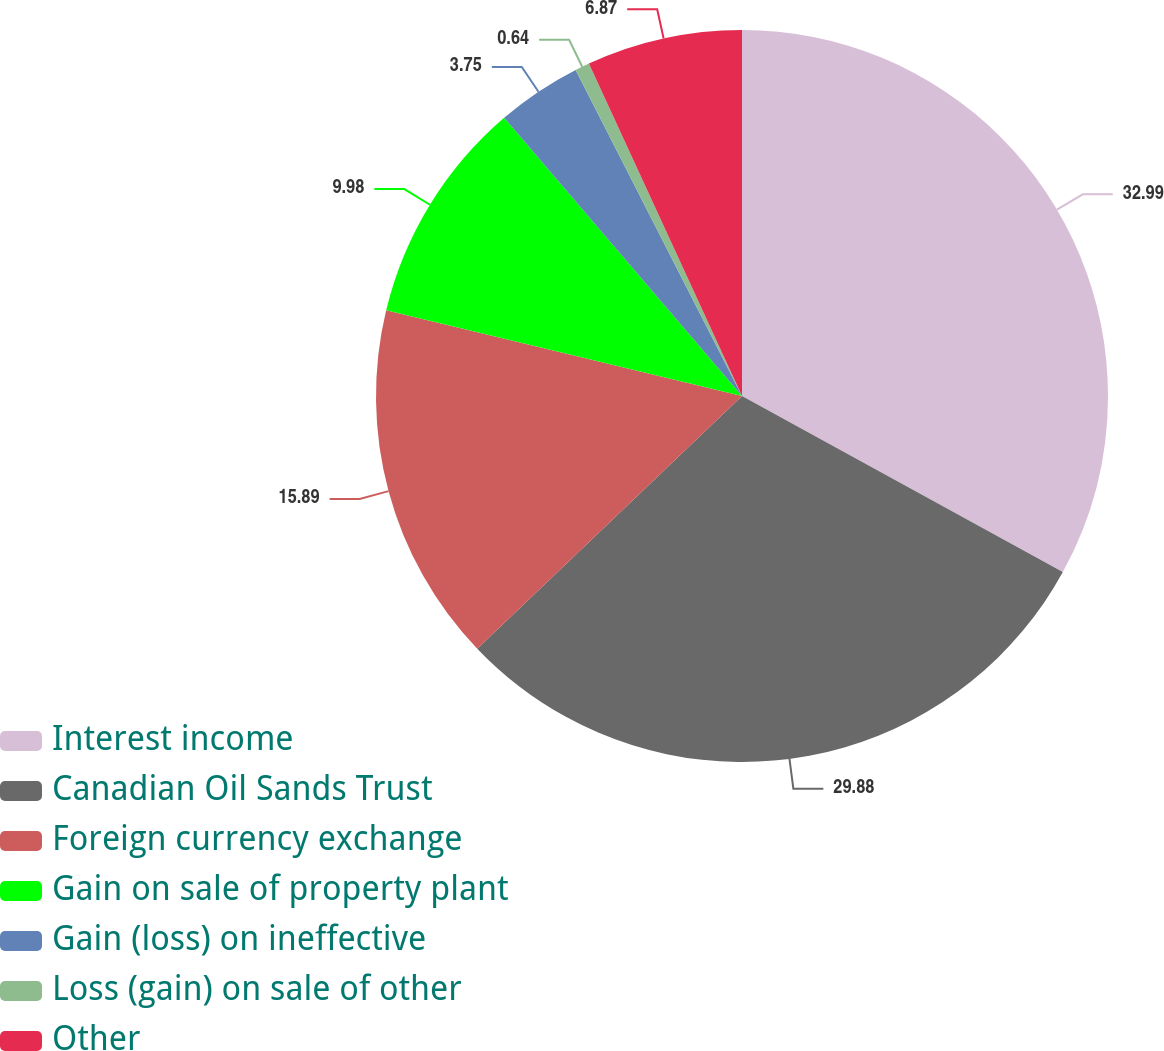Convert chart. <chart><loc_0><loc_0><loc_500><loc_500><pie_chart><fcel>Interest income<fcel>Canadian Oil Sands Trust<fcel>Foreign currency exchange<fcel>Gain on sale of property plant<fcel>Gain (loss) on ineffective<fcel>Loss (gain) on sale of other<fcel>Other<nl><fcel>32.99%<fcel>29.88%<fcel>15.89%<fcel>9.98%<fcel>3.75%<fcel>0.64%<fcel>6.87%<nl></chart> 